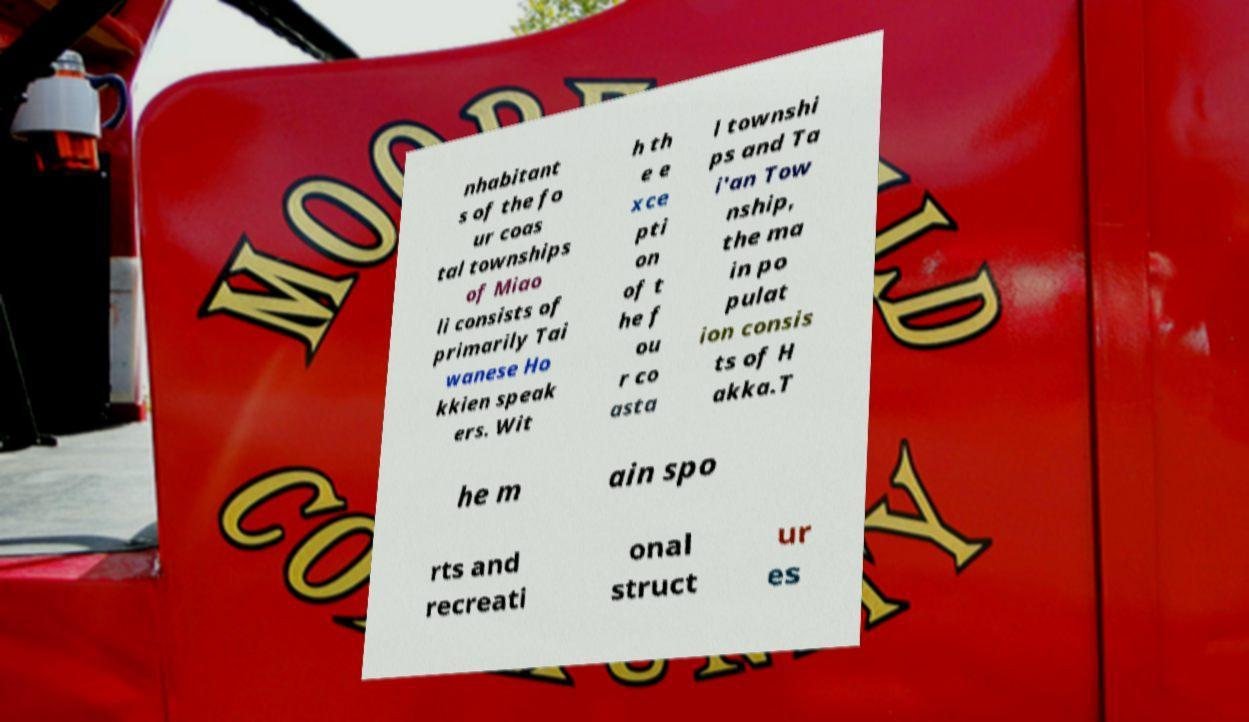Please read and relay the text visible in this image. What does it say? nhabitant s of the fo ur coas tal townships of Miao li consists of primarily Tai wanese Ho kkien speak ers. Wit h th e e xce pti on of t he f ou r co asta l townshi ps and Ta i'an Tow nship, the ma in po pulat ion consis ts of H akka.T he m ain spo rts and recreati onal struct ur es 